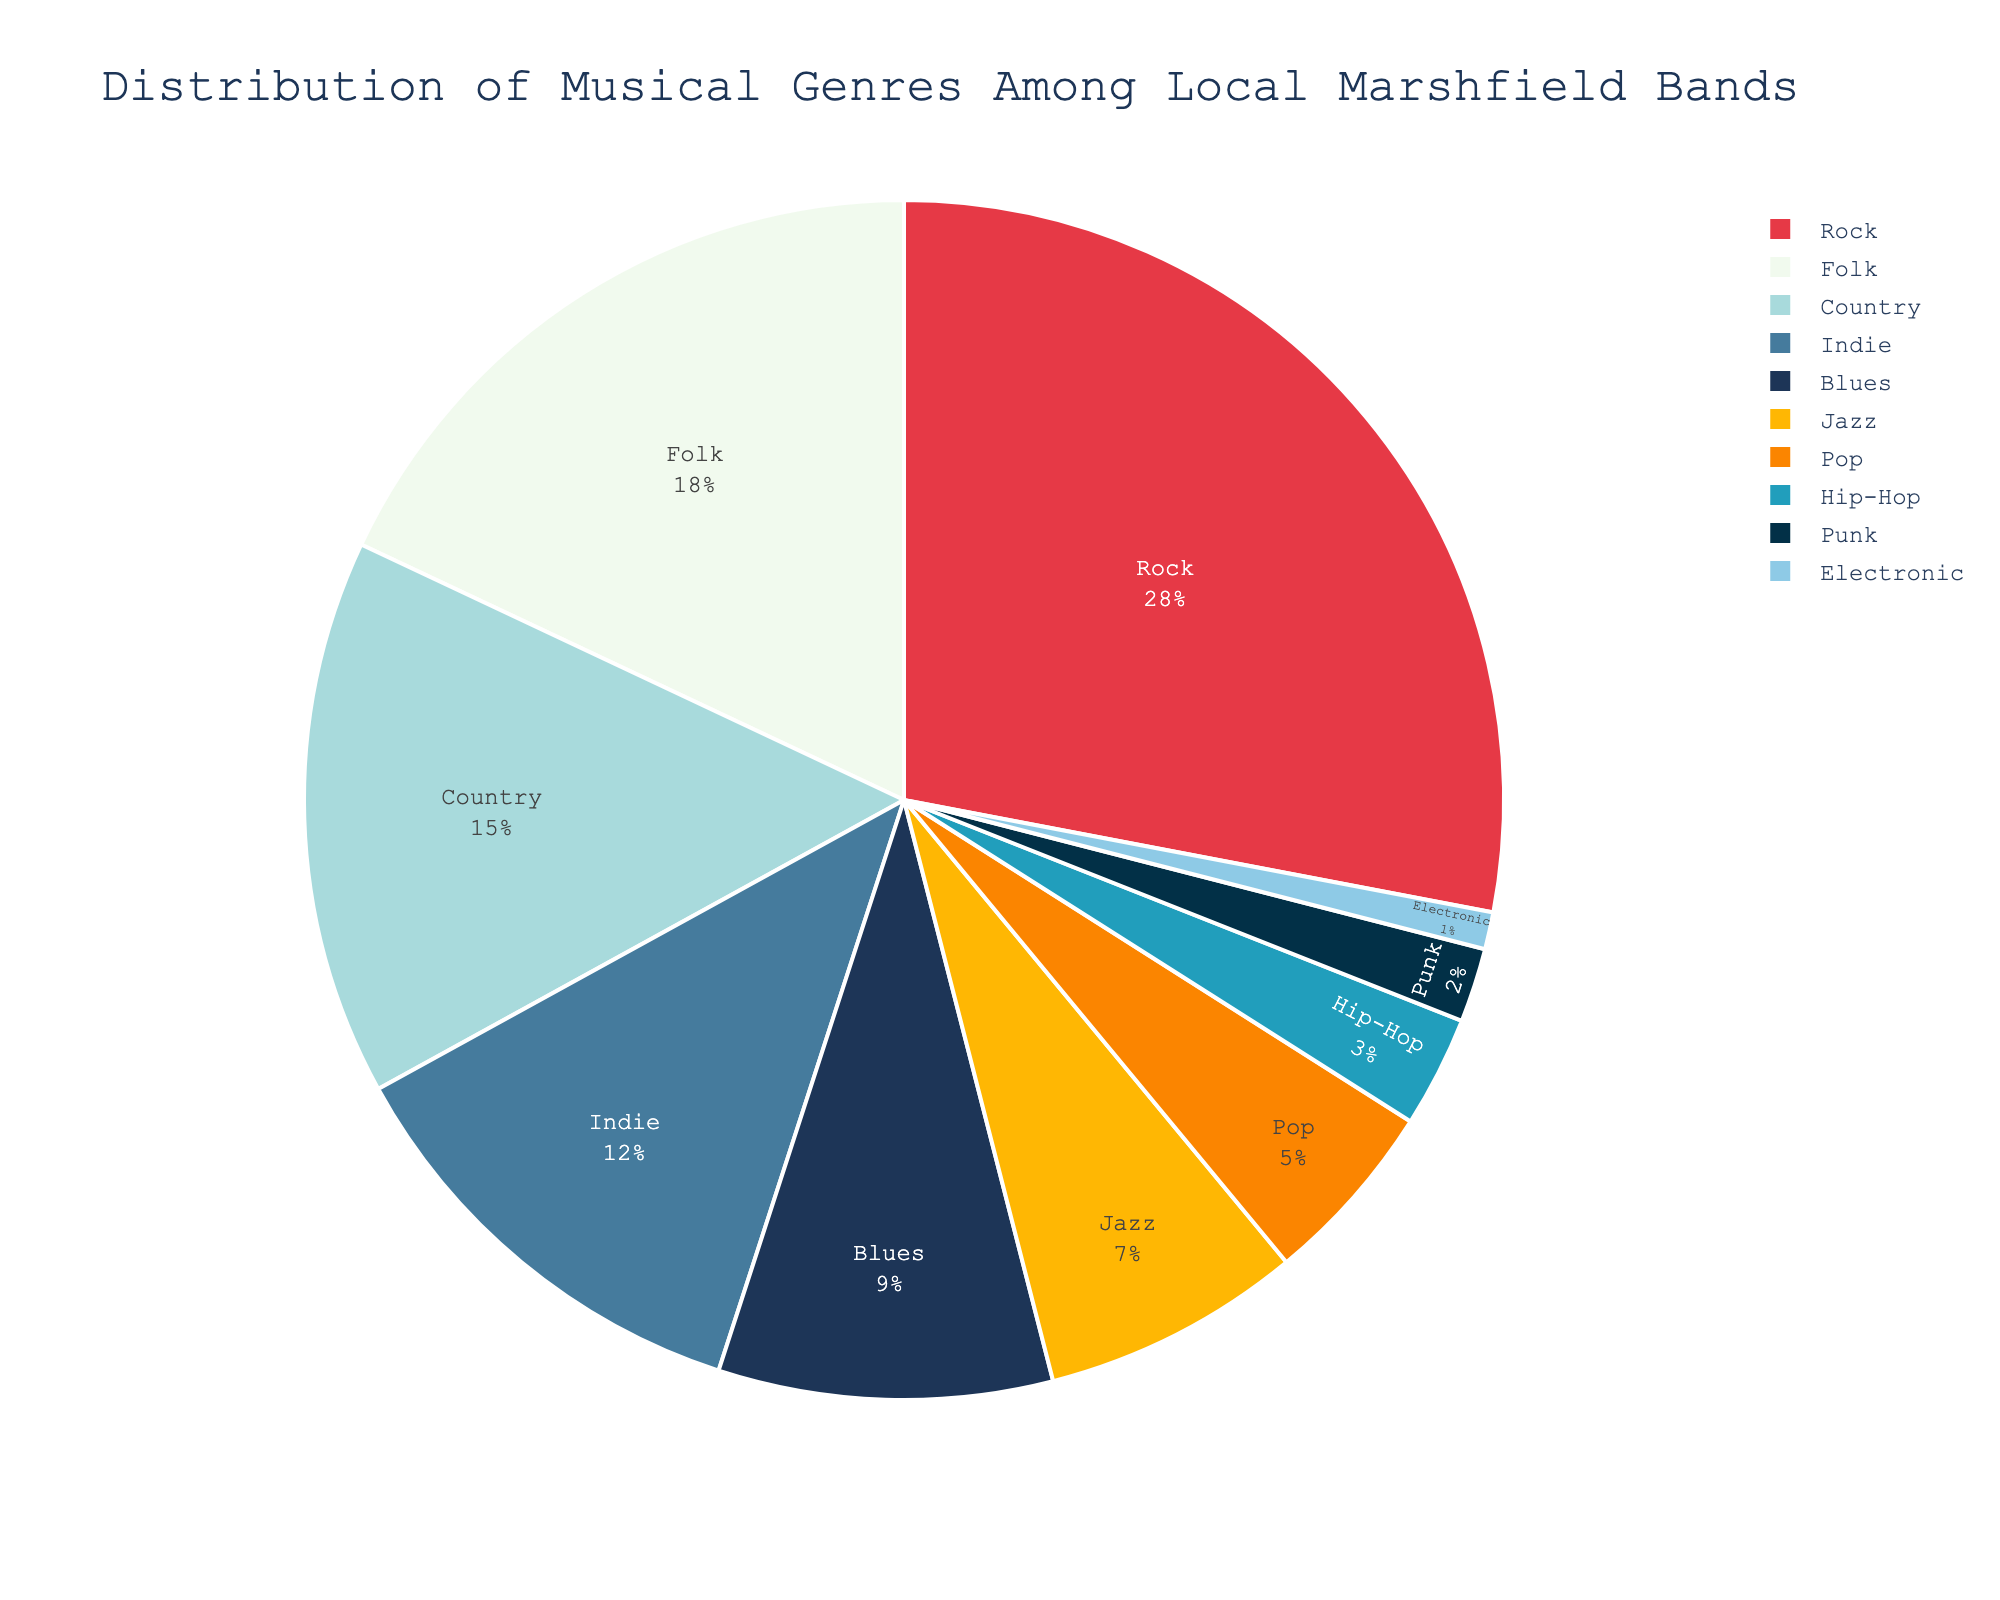What genre has the highest percentage among local Marshfield bands? The pie chart shows the percentages of different musical genres, and the segment with the largest proportion is labeled "Rock" with 28%.
Answer: Rock Which genre holds the smallest share in the distribution? The pie chart has segments representing each genre, and the smallest segment is labeled "Electronic" with 1%.
Answer: Electronic How much greater is the percentage of Rock compared to Folk? From the chart, Rock is 28% and Folk is 18%. Subtracting these, 28% - 18% = 10%.
Answer: 10% If you combine the percentages of Indie and Blues, does it surpass Folk? Indie is 12% and Blues is 9%. Adding them results in 12% + 9% = 21%, and Folk is 18%. Since 21% is greater than 18%, Indie and Blues together surpass Folk.
Answer: Yes Which genre has a larger share, Pop or Jazz? According to the pie chart, Pop has 5% and Jazz has 7%. Since 7% is greater than 5%, Jazz has a larger share than Pop.
Answer: Jazz Out of Country, Indie, and Blues, which genre has the median percentage? The percentages for Country, Indie, and Blues are 15%, 12%, and 9% respectively. Sorting these values: 9%, 12%, 15%, the median value is at the center, which is 12%.
Answer: Indie What is the combined percentage of all genres less than 10%? The genres below 10% are Blues (9%), Jazz (7%), Pop (5%), Hip-Hop (3%), Punk (2%), and Electronic (1%). Adding these, 9% + 7% + 5% + 3% + 2% + 1% = 27%.
Answer: 27% If the Indie percentage were to double, what would be its new percentage? The current percentage of Indie is 12%. Doubling 12% results in 12% * 2 = 24%.
Answer: 24% Is there any genre more than twice as popular as Jazz? Jazz has 7%. Twice this is 7% * 2 = 14%. Checking the chart, genres with more than 14% are Rock (28%) and Folk (18%) which both exceed twice the Jazz percentage.
Answer: Yes 